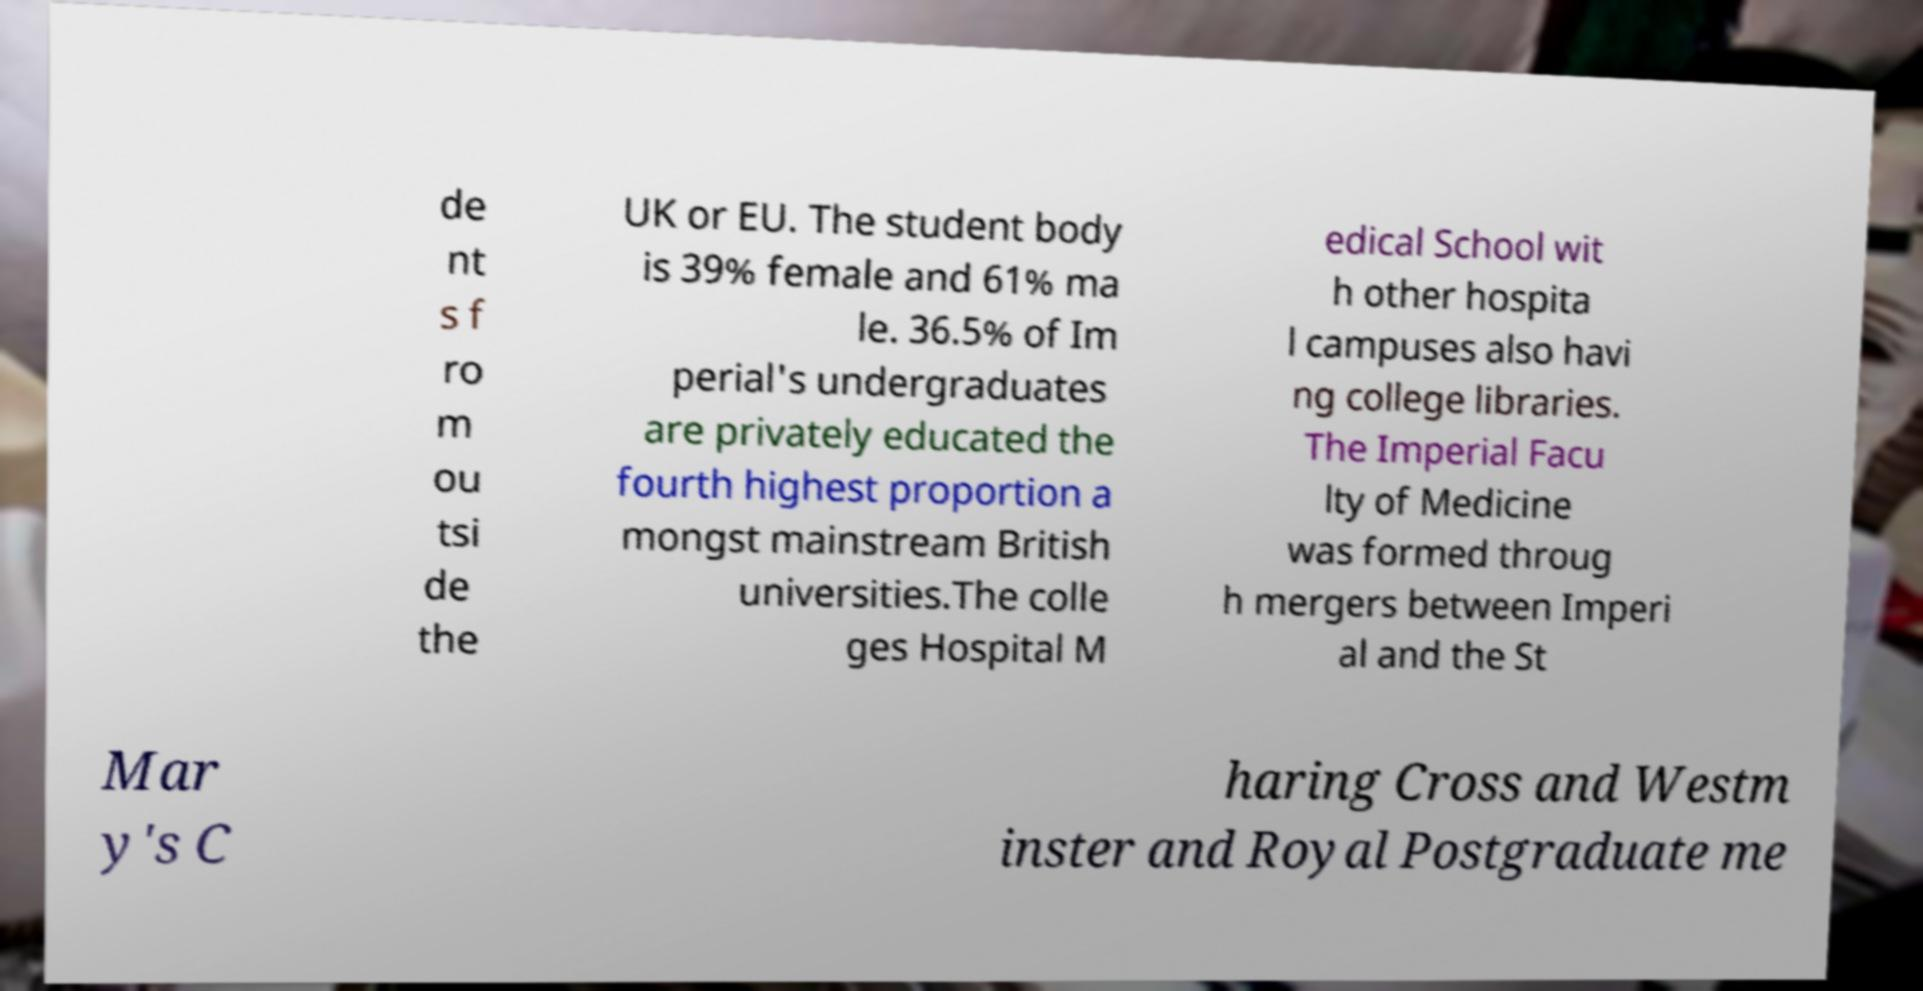There's text embedded in this image that I need extracted. Can you transcribe it verbatim? de nt s f ro m ou tsi de the UK or EU. The student body is 39% female and 61% ma le. 36.5% of Im perial's undergraduates are privately educated the fourth highest proportion a mongst mainstream British universities.The colle ges Hospital M edical School wit h other hospita l campuses also havi ng college libraries. The Imperial Facu lty of Medicine was formed throug h mergers between Imperi al and the St Mar y's C haring Cross and Westm inster and Royal Postgraduate me 